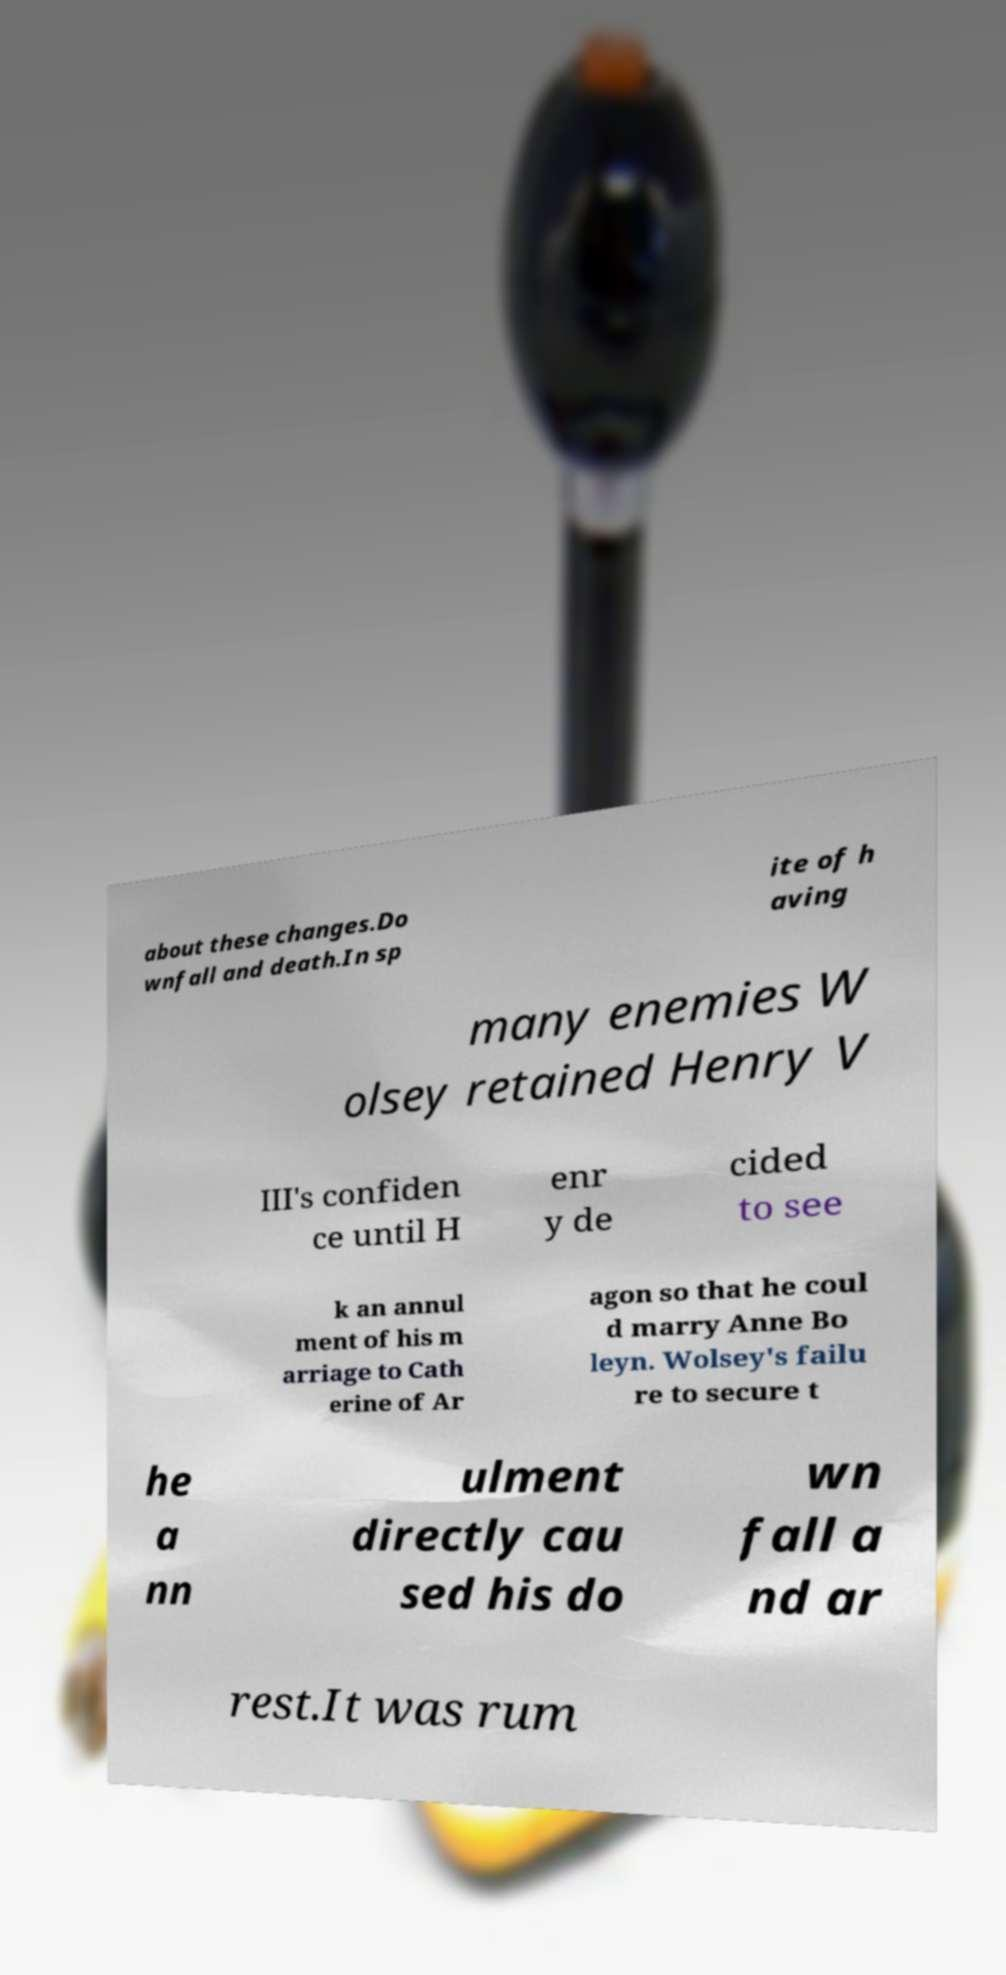For documentation purposes, I need the text within this image transcribed. Could you provide that? about these changes.Do wnfall and death.In sp ite of h aving many enemies W olsey retained Henry V III's confiden ce until H enr y de cided to see k an annul ment of his m arriage to Cath erine of Ar agon so that he coul d marry Anne Bo leyn. Wolsey's failu re to secure t he a nn ulment directly cau sed his do wn fall a nd ar rest.It was rum 